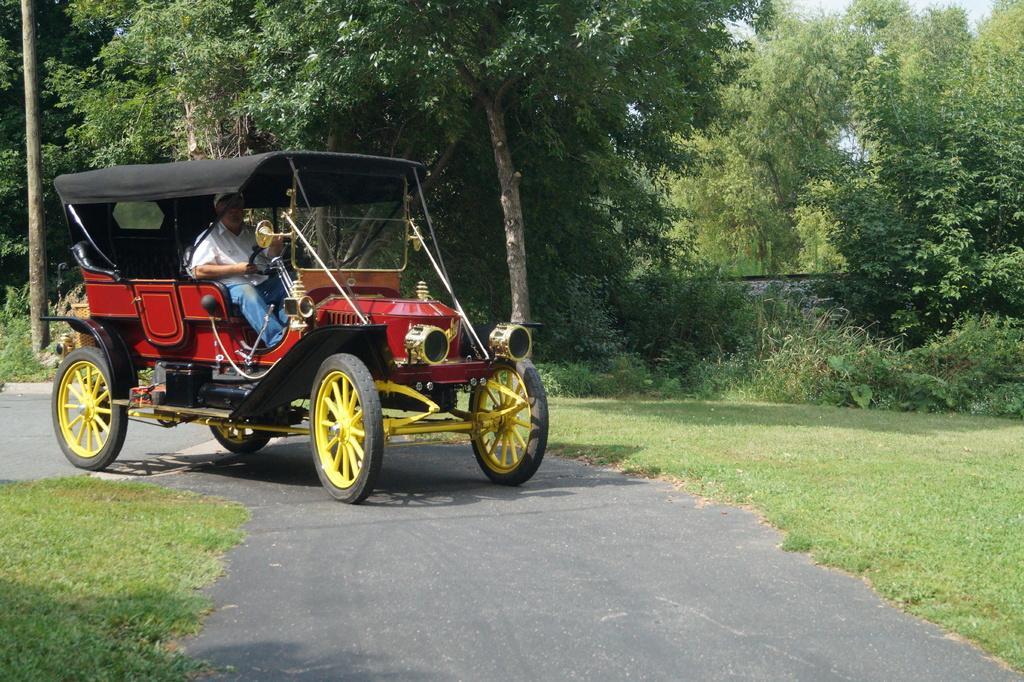Can you describe this image briefly? In the picture we can see a car which is a very old model, in that we can see a man sitting and driving it and on the either sides of the road we can see grass surfaces, plants and trees. 